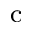<formula> <loc_0><loc_0><loc_500><loc_500>^ { c }</formula> 